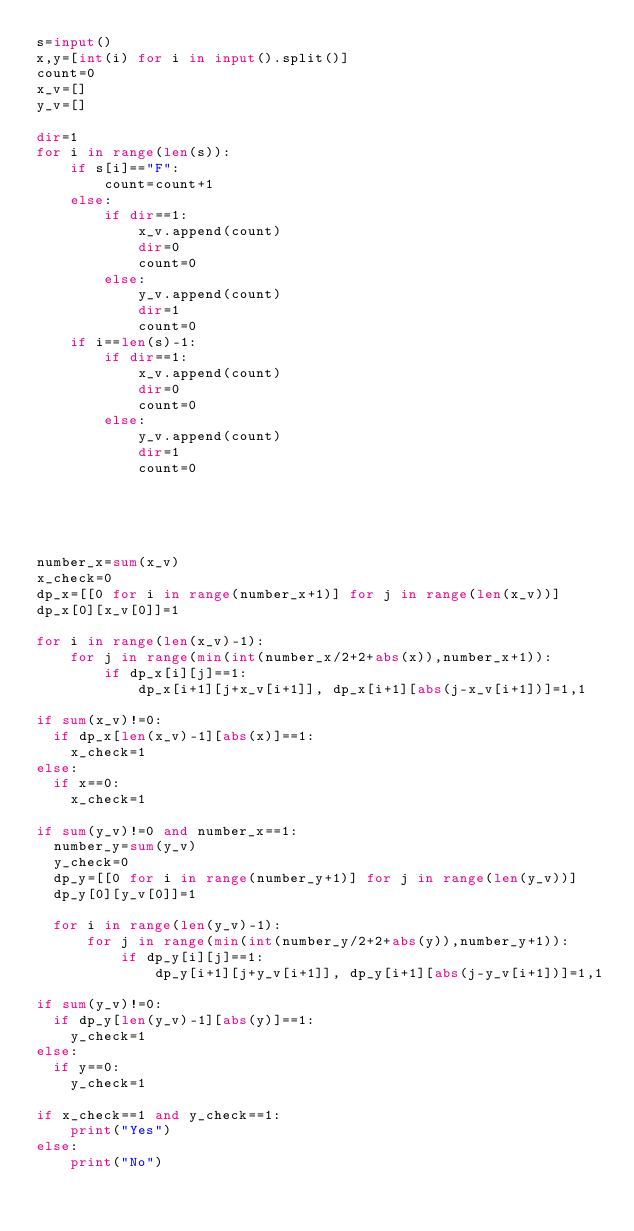Convert code to text. <code><loc_0><loc_0><loc_500><loc_500><_Python_>s=input()
x,y=[int(i) for i in input().split()]
count=0
x_v=[]
y_v=[]

dir=1
for i in range(len(s)):
    if s[i]=="F":
        count=count+1
    else:
        if dir==1:
            x_v.append(count)
            dir=0
            count=0
        else:
            y_v.append(count)
            dir=1
            count=0
    if i==len(s)-1:
        if dir==1:
            x_v.append(count)
            dir=0
            count=0
        else:
            y_v.append(count)
            dir=1
            count=0        





number_x=sum(x_v)
x_check=0
dp_x=[[0 for i in range(number_x+1)] for j in range(len(x_v))]
dp_x[0][x_v[0]]=1

for i in range(len(x_v)-1):
    for j in range(min(int(number_x/2+2+abs(x)),number_x+1)):
        if dp_x[i][j]==1:
            dp_x[i+1][j+x_v[i+1]], dp_x[i+1][abs(j-x_v[i+1])]=1,1

if sum(x_v)!=0:
  if dp_x[len(x_v)-1][abs(x)]==1:
    x_check=1
else:
  if x==0:
    x_check=1  

if sum(y_v)!=0 and number_x==1:
  number_y=sum(y_v)
  y_check=0
  dp_y=[[0 for i in range(number_y+1)] for j in range(len(y_v))]
  dp_y[0][y_v[0]]=1

  for i in range(len(y_v)-1):
      for j in range(min(int(number_y/2+2+abs(y)),number_y+1)):
          if dp_y[i][j]==1:
              dp_y[i+1][j+y_v[i+1]], dp_y[i+1][abs(j-y_v[i+1])]=1,1

if sum(y_v)!=0:
  if dp_y[len(y_v)-1][abs(y)]==1:
    y_check=1
else:
  if y==0:
    y_check=1

if x_check==1 and y_check==1:
    print("Yes")
else:
    print("No")</code> 